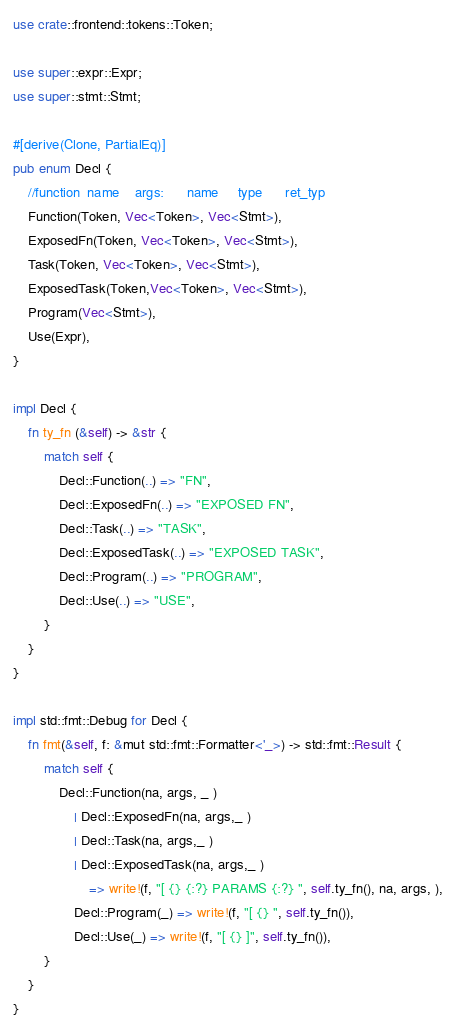<code> <loc_0><loc_0><loc_500><loc_500><_Rust_>
use crate::frontend::tokens::Token;

use super::expr::Expr;
use super::stmt::Stmt;

#[derive(Clone, PartialEq)]
pub enum Decl {
    //function  name    args:      name     type      ret_typ   
    Function(Token, Vec<Token>, Vec<Stmt>),
    ExposedFn(Token, Vec<Token>, Vec<Stmt>),
    Task(Token, Vec<Token>, Vec<Stmt>),
    ExposedTask(Token,Vec<Token>, Vec<Stmt>),
    Program(Vec<Stmt>),
    Use(Expr),
}

impl Decl {
    fn ty_fn (&self) -> &str {
        match self {
            Decl::Function(..) => "FN",
            Decl::ExposedFn(..) => "EXPOSED FN",
            Decl::Task(..) => "TASK",
            Decl::ExposedTask(..) => "EXPOSED TASK",
            Decl::Program(..) => "PROGRAM",
            Decl::Use(..) => "USE",
        }
    }
}

impl std::fmt::Debug for Decl {
    fn fmt(&self, f: &mut std::fmt::Formatter<'_>) -> std::fmt::Result {
        match self {
            Decl::Function(na, args, _ )
                | Decl::ExposedFn(na, args,_ )
                | Decl::Task(na, args,_ )
                | Decl::ExposedTask(na, args,_ ) 
                    => write!(f, "[ {} {:?} PARAMS {:?} ", self.ty_fn(), na, args, ),
                Decl::Program(_) => write!(f, "[ {} ", self.ty_fn()),
                Decl::Use(_) => write!(f, "[ {} ]", self.ty_fn()),
        }
    }
}
</code> 